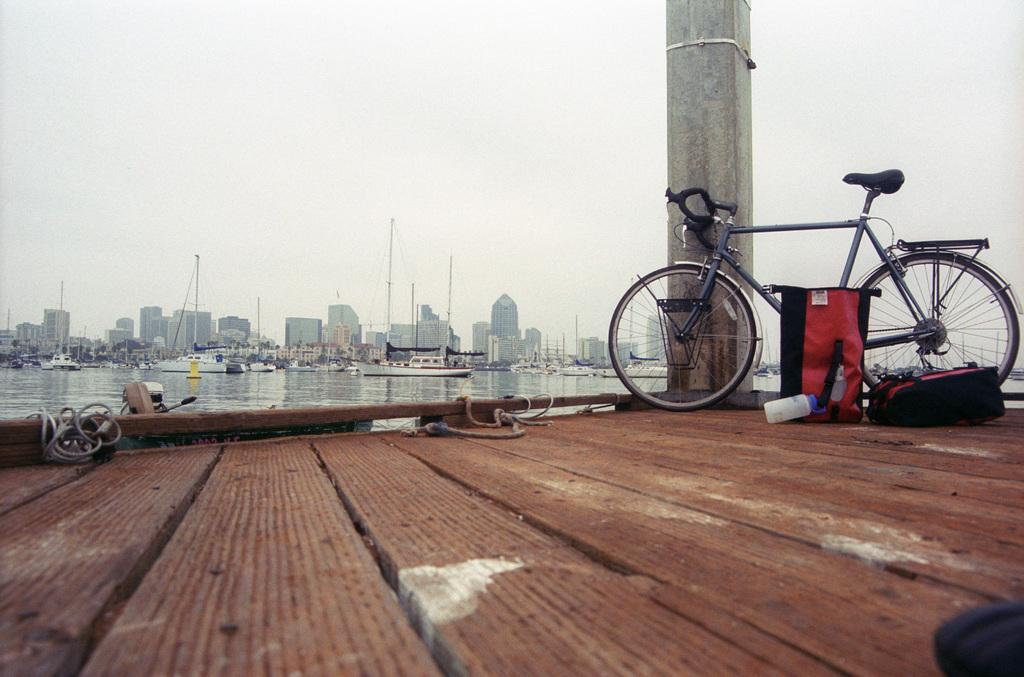What type of structures can be seen in the image? There are many buildings in the image. What mode of transportation is present in the image? There are watercraft vehicles in the image. Can you describe the bike in the image? A bike is parked beside a parked beside a pillar in the image. What material is the floor made of? The floor is made of wood. What type of hose is connected to the bike's mouth in the image? There is no hose connected to the bike's mouth in the image, as bikes do not have mouths. 